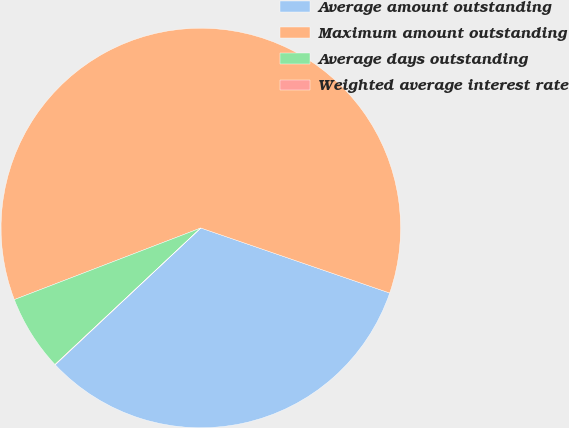Convert chart. <chart><loc_0><loc_0><loc_500><loc_500><pie_chart><fcel>Average amount outstanding<fcel>Maximum amount outstanding<fcel>Average days outstanding<fcel>Weighted average interest rate<nl><fcel>32.72%<fcel>61.12%<fcel>6.14%<fcel>0.03%<nl></chart> 